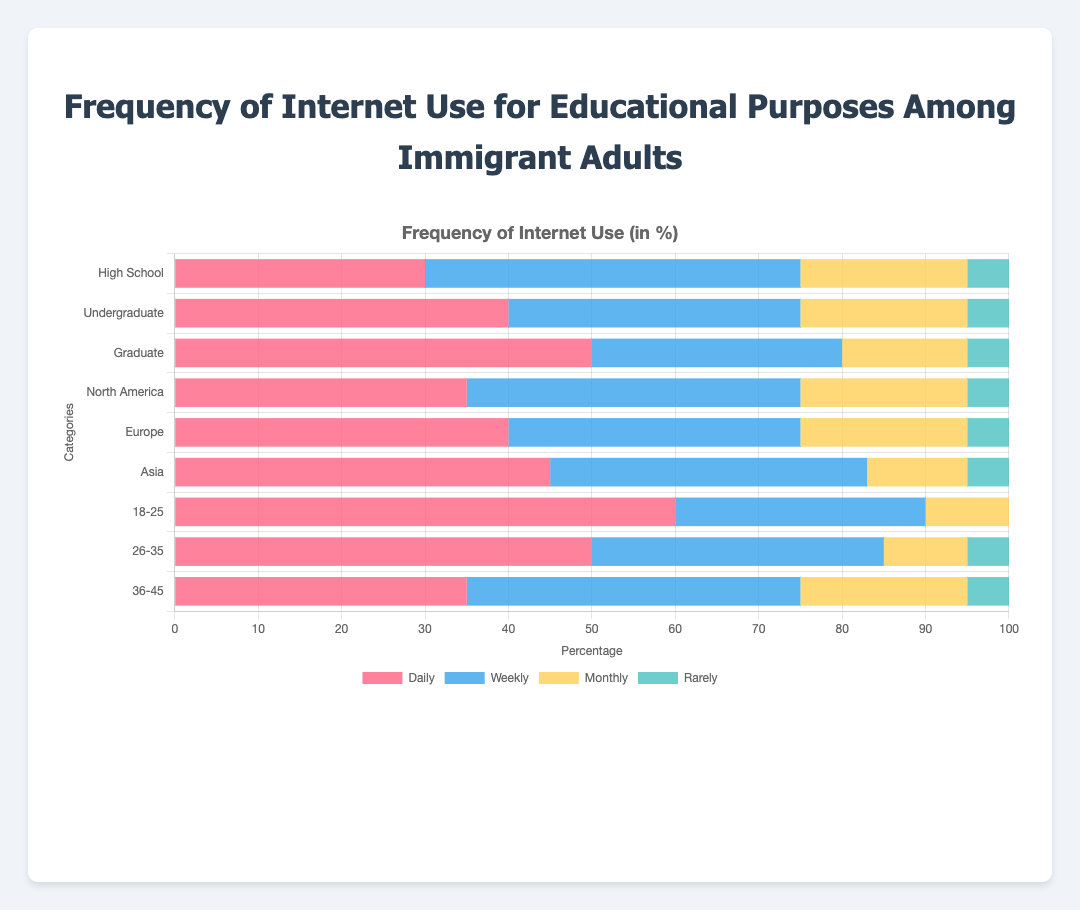1. Which age group has the highest daily internet use for educational purposes? Look at the bar representing 'Daily' internet use for each age group. The '18-25' group has the tallest red bar.
Answer: 18-25 2. What is the total percentage of people who use the internet monthly for educational purposes across all education levels? Add the bars labeled 'Monthly' for the 'High School', 'Undergraduate', and 'Graduate' categories: 20 + 20 + 15 = 55%.
Answer: 55% 3. Among the regions, which one has the lowest weekly internet use for educational purposes? Compare the heights of the blue bars for 'Weekly' across 'North America', 'Europe', and 'Asia'. 'Europe' has the lowest weekly use at 35%.
Answer: Europe 4. How much more frequently do 26-35 year-olds use the internet daily compared to 36-45 year-olds? Subtract the daily usage percentage of the '36-45' age group from the '26-35' age group: 50 - 35 = 15%.
Answer: 15% 5. Which has a higher percentage of monthly internet usage for educational purposes, undergraduates or North America? Compare the yellow bars labeled 'Monthly' for 'Undergraduate' (20%) and 'North America' (20%). Both are equal.
Answer: Equal 6. What is the combined total of daily and weekly internet usage for the 'Graduate' education level? Add the daily and weekly usage percentages for 'Graduate': 50% (red) + 30% (blue) = 80%.
Answer: 80% 7. How does the rarely use category compare across all categories in the chart? The 'Rarely' usage bars (green) are consistently at 5% for all categories except the '18-25' age group, which is at 0%.
Answer: 5% except 18-25 at 0% 8. Which category (education level, region, or age group) has the smallest percentage of monthly internet use for educational purposes, and what is that percentage? Look for the smallest yellow bar under 'Monthly' across all categories. The 'Asia' region has the smallest monthly use at 12%.
Answer: Asia, 12% 9. Calculate the average percentage of 'Weekly' internet use for educational purposes among the regions. Sum the weekly usage percentages for 'North America', 'Europe', and 'Asia', then divide by 3: (40% + 35% + 38%) / 3 = 113% / 3 = 37.67%.
Answer: 37.67% 10. Between high school and undergraduate education levels, which one has a higher daily internet use percentage, and by how much? Compare the 'Daily' usage percentages for 'High School' (30%) and 'Undergraduate' (40%). Subtract the values: 40% - 30% = 10%.
Answer: Undergraduate, 10% 